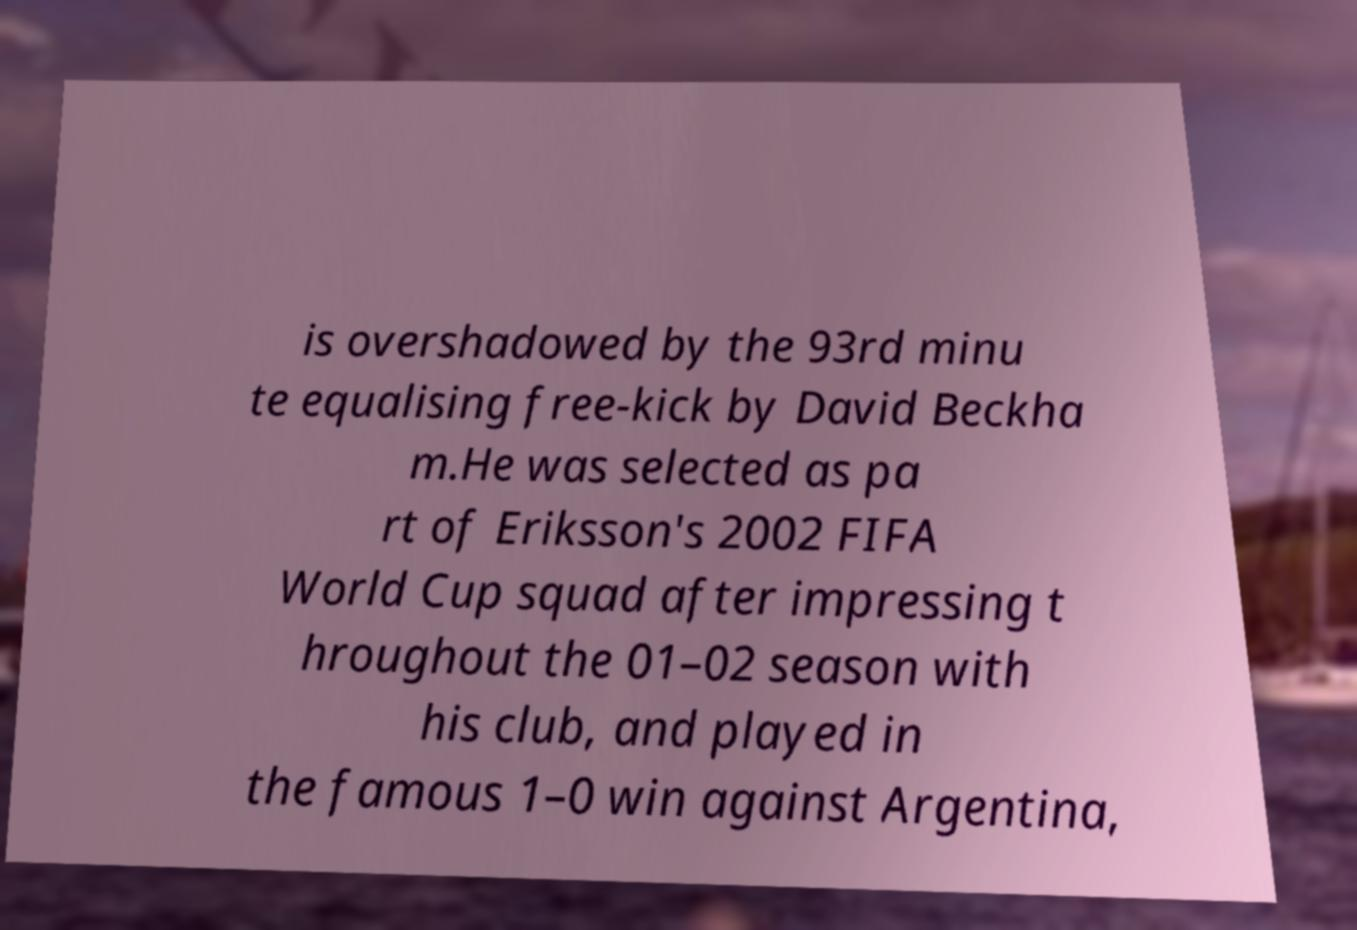For documentation purposes, I need the text within this image transcribed. Could you provide that? is overshadowed by the 93rd minu te equalising free-kick by David Beckha m.He was selected as pa rt of Eriksson's 2002 FIFA World Cup squad after impressing t hroughout the 01–02 season with his club, and played in the famous 1–0 win against Argentina, 